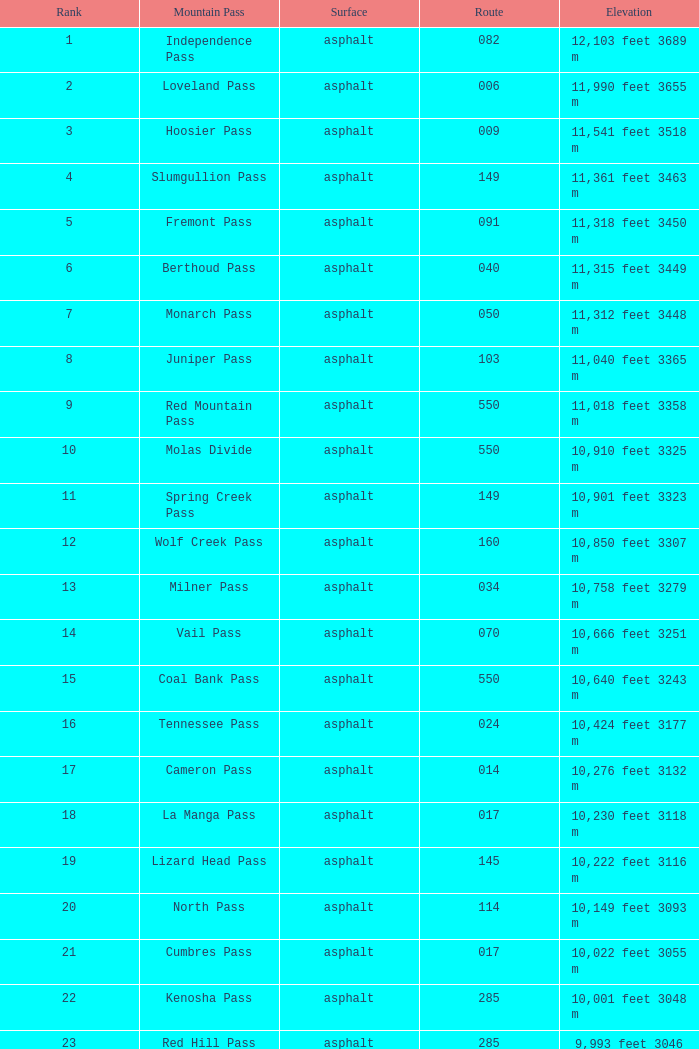Would you be able to parse every entry in this table? {'header': ['Rank', 'Mountain Pass', 'Surface', 'Route', 'Elevation'], 'rows': [['1', 'Independence Pass', 'asphalt', '082', '12,103 feet 3689 m'], ['2', 'Loveland Pass', 'asphalt', '006', '11,990 feet 3655 m'], ['3', 'Hoosier Pass', 'asphalt', '009', '11,541 feet 3518 m'], ['4', 'Slumgullion Pass', 'asphalt', '149', '11,361 feet 3463 m'], ['5', 'Fremont Pass', 'asphalt', '091', '11,318 feet 3450 m'], ['6', 'Berthoud Pass', 'asphalt', '040', '11,315 feet 3449 m'], ['7', 'Monarch Pass', 'asphalt', '050', '11,312 feet 3448 m'], ['8', 'Juniper Pass', 'asphalt', '103', '11,040 feet 3365 m'], ['9', 'Red Mountain Pass', 'asphalt', '550', '11,018 feet 3358 m'], ['10', 'Molas Divide', 'asphalt', '550', '10,910 feet 3325 m'], ['11', 'Spring Creek Pass', 'asphalt', '149', '10,901 feet 3323 m'], ['12', 'Wolf Creek Pass', 'asphalt', '160', '10,850 feet 3307 m'], ['13', 'Milner Pass', 'asphalt', '034', '10,758 feet 3279 m'], ['14', 'Vail Pass', 'asphalt', '070', '10,666 feet 3251 m'], ['15', 'Coal Bank Pass', 'asphalt', '550', '10,640 feet 3243 m'], ['16', 'Tennessee Pass', 'asphalt', '024', '10,424 feet 3177 m'], ['17', 'Cameron Pass', 'asphalt', '014', '10,276 feet 3132 m'], ['18', 'La Manga Pass', 'asphalt', '017', '10,230 feet 3118 m'], ['19', 'Lizard Head Pass', 'asphalt', '145', '10,222 feet 3116 m'], ['20', 'North Pass', 'asphalt', '114', '10,149 feet 3093 m'], ['21', 'Cumbres Pass', 'asphalt', '017', '10,022 feet 3055 m'], ['22', 'Kenosha Pass', 'asphalt', '285', '10,001 feet 3048 m'], ['23', 'Red Hill Pass', 'asphalt', '285', '9,993 feet 3046 m'], ['24', 'Cucharas Pass', 'asphalt', '012', '9,941 feet 3030 m'], ['25', 'Willow Creek Pass', 'asphalt', '125', '9,621 feet 2932 m'], ['26', 'Gore Pass', 'asphalt', '134', '9,527 feet 2904 m'], ['27', 'Wilkerson Pass', 'asphalt', '024', '9,507 feet 2898 m'], ['28', 'Currant Creek Pass', 'asphalt', '009', '9,482 feet 2890 m'], ['29', 'Rabbit Ears Pass', 'asphalt', '040', '9,426 feet 2873 m'], ['30', 'North La Veta Pass', 'asphalt', '160', '9,413 feet 2869 m'], ['31', 'Trout Creek Pass', 'asphalt', '024.285', '9,346 feet 2849 m'], ['32', 'Ute Pass', 'asphalt', '024', '9,165 feet 2793 m'], ['33', 'Wind River Pass', 'asphalt', '007', '9,150 feet 2790 m'], ['34', 'Hardscrabble Pass', 'asphalt', '096', '9,085 feet 2769 m'], ['35', 'Poncha Pass', 'asphalt', '285', '9,010 feet 2746 m'], ['36', 'Dallas Divide', 'asphalt', '062', '8,970 feet 2734 m'], ['37', 'Muddy Pass', 'asphalt', '040', '8,772 feet 2674 m'], ['38', 'McClure Pass', 'asphalt', '133', '8,755 feet 2669 m'], ['39', 'Douglas Pass', 'asphalt', '139', '8,268 feet 2520 m'], ['40', 'Cerro Summit', 'asphalt', '050', '7,958 feet 2423 m'], ['41', 'Raton Pass', 'asphalt', '025', '7,834 feet 2388 m'], ['42', 'Yellowjacket Pass', 'asphalt', '160', '7,783 feet 2372 m'], ['43', 'Monument Hill', 'asphalt', '025', '7,343 feet 2238 m'], ['44', 'Unaweep Divide', 'asphalt', '141', '7,048 feet 2148 m']]} What is the Mountain Pass with a 21 Rank? Cumbres Pass. 